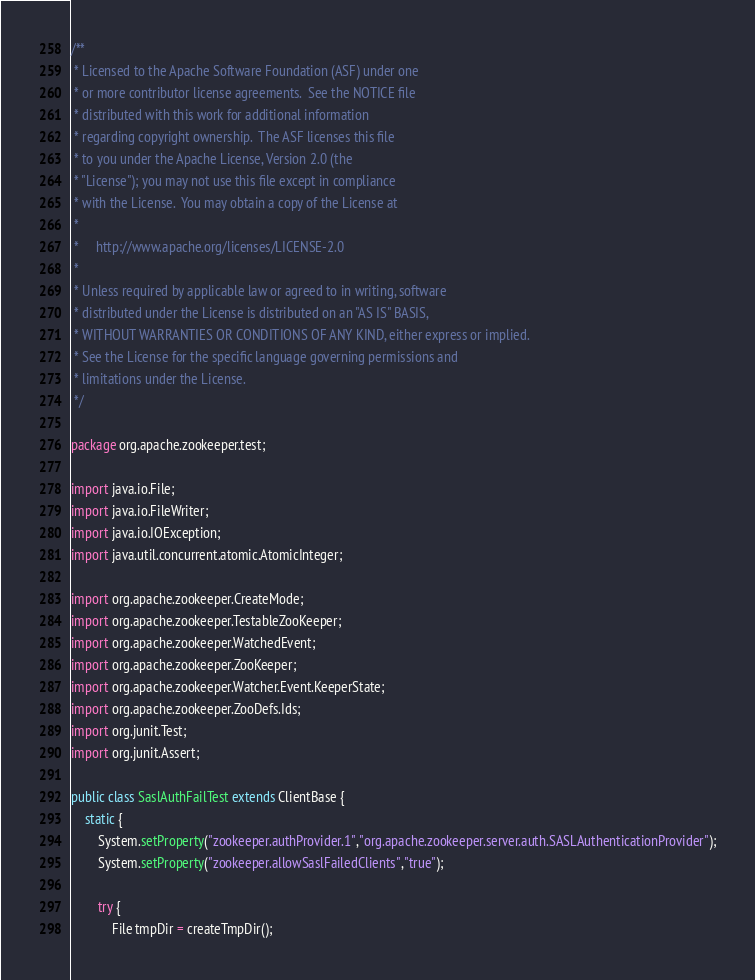Convert code to text. <code><loc_0><loc_0><loc_500><loc_500><_Java_>/**
 * Licensed to the Apache Software Foundation (ASF) under one
 * or more contributor license agreements.  See the NOTICE file
 * distributed with this work for additional information
 * regarding copyright ownership.  The ASF licenses this file
 * to you under the Apache License, Version 2.0 (the
 * "License"); you may not use this file except in compliance
 * with the License.  You may obtain a copy of the License at
 *
 *     http://www.apache.org/licenses/LICENSE-2.0
 *
 * Unless required by applicable law or agreed to in writing, software
 * distributed under the License is distributed on an "AS IS" BASIS,
 * WITHOUT WARRANTIES OR CONDITIONS OF ANY KIND, either express or implied.
 * See the License for the specific language governing permissions and
 * limitations under the License.
 */

package org.apache.zookeeper.test;

import java.io.File;
import java.io.FileWriter;
import java.io.IOException;
import java.util.concurrent.atomic.AtomicInteger;

import org.apache.zookeeper.CreateMode;
import org.apache.zookeeper.TestableZooKeeper;
import org.apache.zookeeper.WatchedEvent;
import org.apache.zookeeper.ZooKeeper;
import org.apache.zookeeper.Watcher.Event.KeeperState;
import org.apache.zookeeper.ZooDefs.Ids;
import org.junit.Test;
import org.junit.Assert;

public class SaslAuthFailTest extends ClientBase {
    static {
        System.setProperty("zookeeper.authProvider.1","org.apache.zookeeper.server.auth.SASLAuthenticationProvider");
        System.setProperty("zookeeper.allowSaslFailedClients","true");

        try {
            File tmpDir = createTmpDir();</code> 